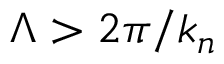<formula> <loc_0><loc_0><loc_500><loc_500>\Lambda > 2 \pi / k _ { n }</formula> 